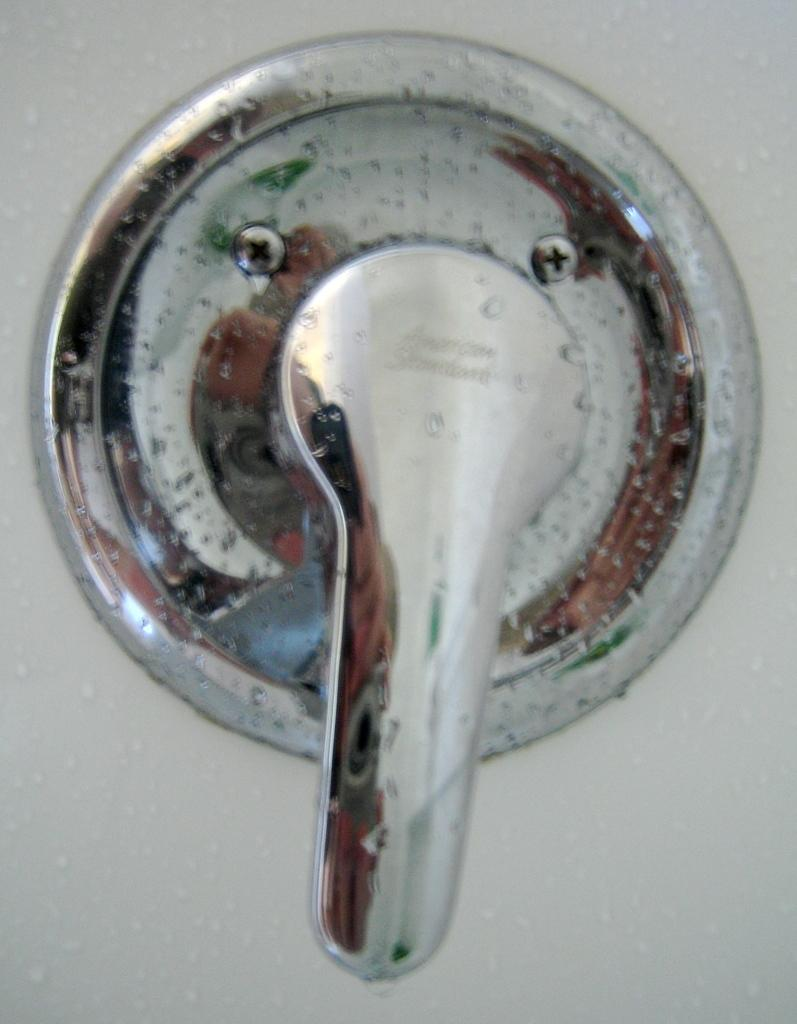What is attached to the wall in the image? There is a tap on the wall in the image. What type of paste is being used to style the hair in the image? There is no hair or paste present in the image; it only features a tap on the wall. How many members are on the team in the image? There is no team present in the image; it only features a tap on the wall. 